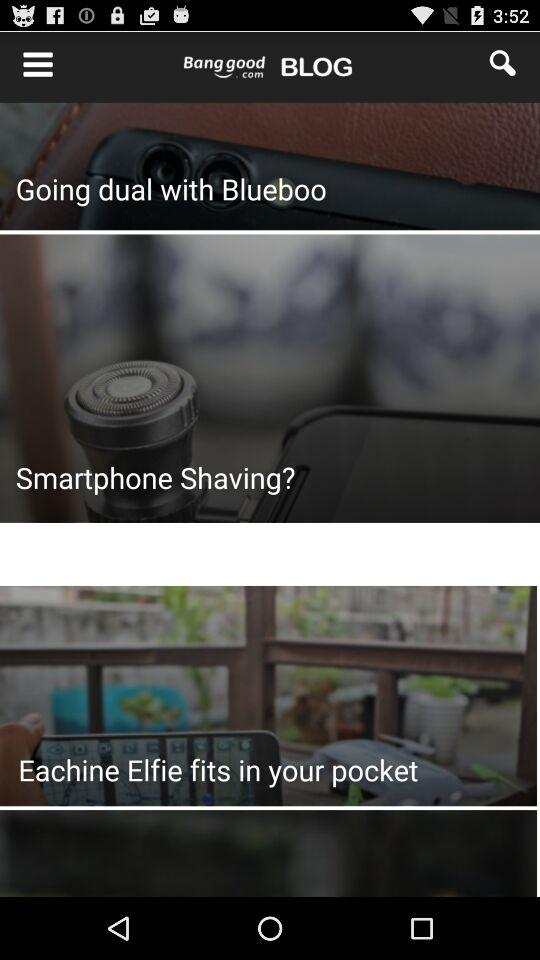How many items are there in the cart? There is only 1 item in the cart. 